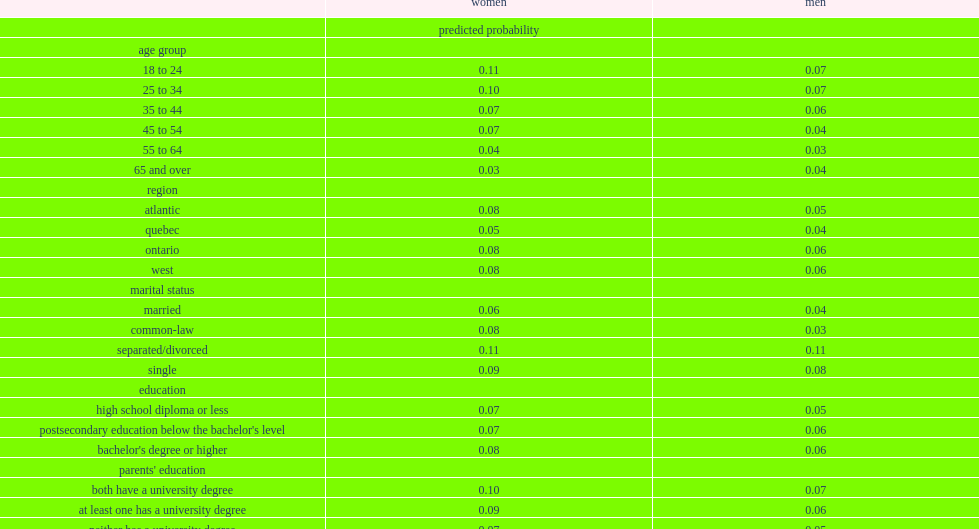Which group had a lower probability of being cyberstalked, women who reported less than $40,000 or women who reported $40,000 to less than $80,000? $40,000 to $79,999. Which group had a lower probability of being cyberstalked, women who reported less than $40,000 or women who reported $80,000 or more? $80,000 or more. Give me the full table as a dictionary. {'header': ['', 'women', 'men'], 'rows': [['', 'predicted probability', ''], ['age group', '', ''], ['18 to 24', '0.11', '0.07'], ['25 to 34', '0.10', '0.07'], ['35 to 44', '0.07', '0.06'], ['45 to 54', '0.07', '0.04'], ['55 to 64', '0.04', '0.03'], ['65 and over', '0.03', '0.04'], ['region', '', ''], ['atlantic', '0.08', '0.05'], ['quebec', '0.05', '0.04'], ['ontario', '0.08', '0.06'], ['west', '0.08', '0.06'], ['marital status', '', ''], ['married', '0.06', '0.04'], ['common-law', '0.08', '0.03'], ['separated/divorced', '0.11', '0.11'], ['single', '0.09', '0.08'], ['education', '', ''], ['high school diploma or less', '0.07', '0.05'], ["postsecondary education below the bachelor's level", '0.07', '0.06'], ["bachelor's degree or higher", '0.08', '0.06'], ["parents' education", '', ''], ['both have a university degree', '0.10', '0.07'], ['at least one has a university degree', '0.09', '0.06'], ['neither has a university degree', '0.07', '0.05'], ["do not know either parent's education level", '0.04', '0.05'], ['household income', '', ''], ['less than $40,000', '0.11', '0.04'], ['$40,000 to $79,999', '0.07', '0.06'], ['$80,000 or more', '0.07', '0.05'], ['not stated', '0.08', '0.06'], ['aboriginal identity', '', ''], ['aboriginal', '0.09', '0.06'], ['non-aboriginal', '0.07', '0.05'], ["respondent's birthplace", '', ''], ['born in canada', '0.08', '0.05'], ['born outside canada', '0.07', '0.06'], ['visible minority status', '', ''], ['visible minority', '0.06', '0.04'], ['not a visible minority', '0.08', '0.06'], ['sexual orientation', '', ''], ['heterosexual', '0.08', '0.05'], ['homosexual/bisexual', '0.07', '0.07'], ['experience of abuse before age 15', '', ''], ['experienced physical abuse or sexual abuse', '0.10', '0.07'], ['experienced both physical and sexual abuse', '0.15', '0.14'], ['none', '0.06', '0.04'], ['witnessed violence involving at least one parent before age 15', '', ''], ['yes', '0.10', '0.08'], ['no', '0.07', '0.05'], ['experienced discrimination in the past five years', '', ''], ['yes', '0.13', '0.10'], ['no', '0.06', '0.04']]} 